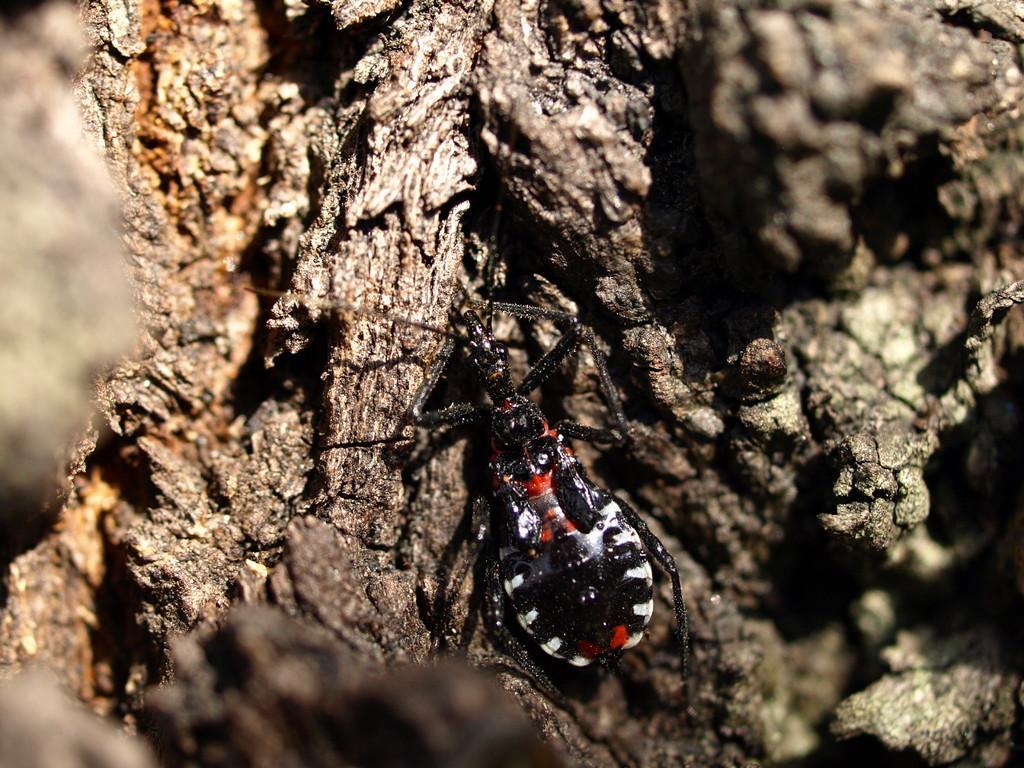Describe this image in one or two sentences. In this picture there is an insect on the trunk of a tree. 